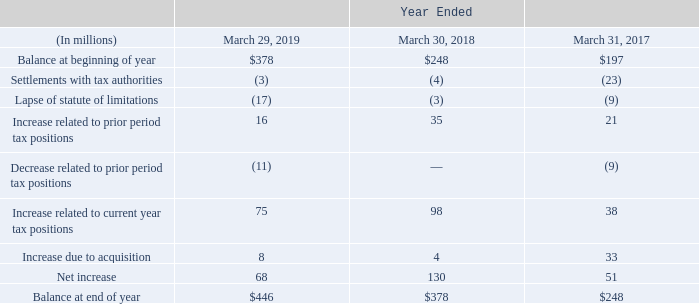In assessing the ability to realize our deferred tax assets, we considered whether it is more likely than not that some portion or all the deferred tax assets will not be realized. We considered the following: we have historical cumulative book income, as measured by the current and prior two years; we have strong, consistent taxpaying history; we have substantial U.S. federal income tax carryback potential; and we have substantial amounts of scheduled future reversals of taxable temporary differences from our deferred tax liabilities. We have concluded that this positive evidence outweighs the negative evidence and, thus, that the deferred tax assets as of March 29, 2019 are realizable on a ‘‘more likely than not’’ basis.
The aggregate changes in the balance of gross unrecognized tax benefits were as follows:
There was a change of $68 million in gross unrecognized tax benefits during fiscal 2019. This gross liability does not include offsetting tax benefits associated with the correlative effects of potential transfer pricing adjustments, interest deductions, and state income taxes.
Of the total unrecognized tax benefits at March 29, 2019, $361 million, if recognized, would favorably affect our effective tax rate.
We recognize interest and/or penalties related to uncertain tax positions in income tax expense. At March 29, 2019, before any tax benefits, we had $43 million of accrued interest and penalties on unrecognized tax benefits. Interest included in our provision for income taxes was an expense of approximately $17 million for fiscal 2019. If the accrued interest and penalties do not ultimately become payable, amounts accrued will be reduced in the period that such determination is made and reflected as a reduction of the overall income tax provision.
We file income tax returns in the U.S. on a federal basis and in many U.S. state and foreign jurisdictions. Our most significant tax jurisdictions are the U.S., Ireland, and Singapore. Our tax filings remain subject to examination by applicable tax authorities for a certain length of time following the tax year to which those filings relate. Our fiscal years 2014 through 2019 remain subject to examination by the IRS for U.S. federal tax purposes. Our fiscal years prior to 2014 have been settled and closed with the IRS. Our 2015 through 2019 fiscal years remain subject to examination by the appropriate governmental agencies for Irish tax purposes, and our 2014 through 2019 fiscal years remain subject to examination by the appropriate governmental agencies for Singapore tax purposes.
The timing of the resolution of income tax examinations is highly uncertain, and the amounts ultimately paid, if any, upon resolution of the issues raised by the taxing authorities may differ materially from the amounts accrued for each year. Although potential resolution of uncertain tax positions involves multiple tax periods and jurisdictions, it is reasonably possible that the gross unrecognized tax benefits related to these audits could decrease (whether by payment, release, or a combination of both) in the next 12 months by $26 million. Depending on the nature of the settlement or expiration of statutes of limitations, we estimate $26 million could affect our income tax provision and therefore benefit the resulting effective tax rate.
We continue to monitor the progress of ongoing income tax controversies and the impact, if any, of the expected tolling of the statute of limitations in various taxing jurisdictions.
What is the change in gross unrecognized tax benefits during fiscal 2019? $68 million. What is the Balance at beginning of year for Year ended march 29, 2019? 
Answer scale should be: million. $378. What is the Balance at end of year for year ended  March 29, 2019?
Answer scale should be: million. $446. What is the percentage constitution of unrecognized tax benefits, if recognized that would favorably affect effective tax rate for year ended March 29, 2019?
Answer scale should be: percent. 361/446
Answer: 80.94. What is the total Balance at end of year for the fiscal years 2019, 2018, 2017?
Answer scale should be: million. 446+378+248
Answer: 1072. What is the average Balance at end of year for the fiscal years 2019, 2018, 2017?
Answer scale should be: million. (446+378+248)/3
Answer: 357.33. 